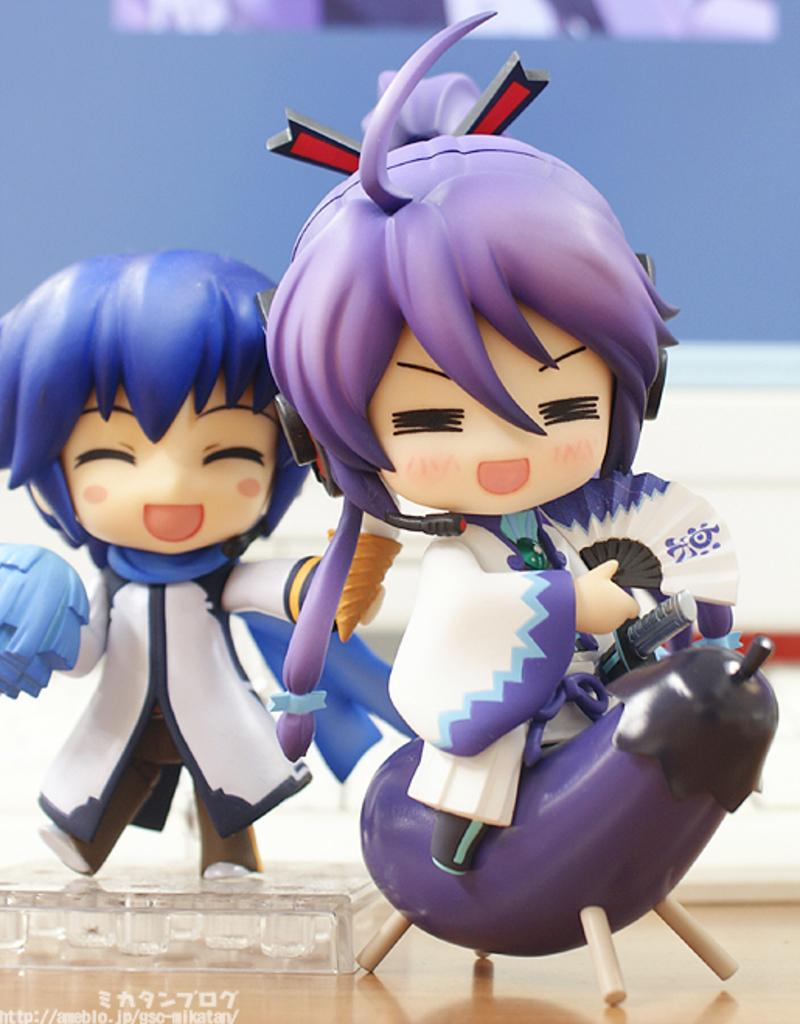How many dolls are present in the image? There are two dolls in the image. What colors are the dolls wearing? One doll is wearing white clothes, and the other doll is wearing purple clothes. What color is the wall in the background of the image? The wall in the background of the image is purple. What type of protest is taking place in the wilderness with frogs in the image? There is no protest or wilderness with frogs present in the image; it features two dolls and a purple wall in the background. 